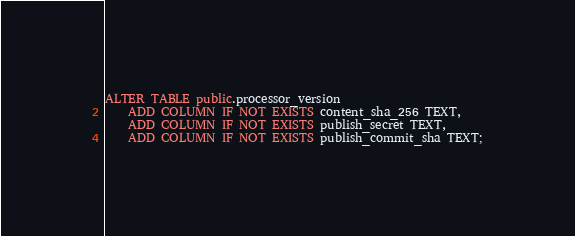<code> <loc_0><loc_0><loc_500><loc_500><_SQL_>ALTER TABLE public.processor_version
    ADD COLUMN IF NOT EXISTS content_sha_256 TEXT,
    ADD COLUMN IF NOT EXISTS publish_secret TEXT,
    ADD COLUMN IF NOT EXISTS publish_commit_sha TEXT;</code> 